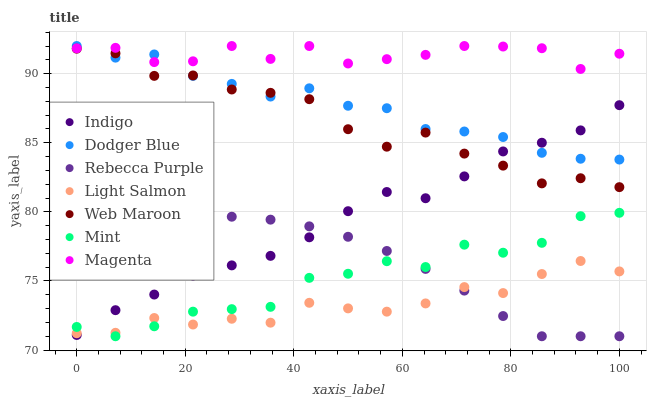Does Light Salmon have the minimum area under the curve?
Answer yes or no. Yes. Does Magenta have the maximum area under the curve?
Answer yes or no. Yes. Does Indigo have the minimum area under the curve?
Answer yes or no. No. Does Indigo have the maximum area under the curve?
Answer yes or no. No. Is Rebecca Purple the smoothest?
Answer yes or no. Yes. Is Mint the roughest?
Answer yes or no. Yes. Is Indigo the smoothest?
Answer yes or no. No. Is Indigo the roughest?
Answer yes or no. No. Does Rebecca Purple have the lowest value?
Answer yes or no. Yes. Does Indigo have the lowest value?
Answer yes or no. No. Does Magenta have the highest value?
Answer yes or no. Yes. Does Indigo have the highest value?
Answer yes or no. No. Is Indigo less than Magenta?
Answer yes or no. Yes. Is Web Maroon greater than Mint?
Answer yes or no. Yes. Does Mint intersect Light Salmon?
Answer yes or no. Yes. Is Mint less than Light Salmon?
Answer yes or no. No. Is Mint greater than Light Salmon?
Answer yes or no. No. Does Indigo intersect Magenta?
Answer yes or no. No. 